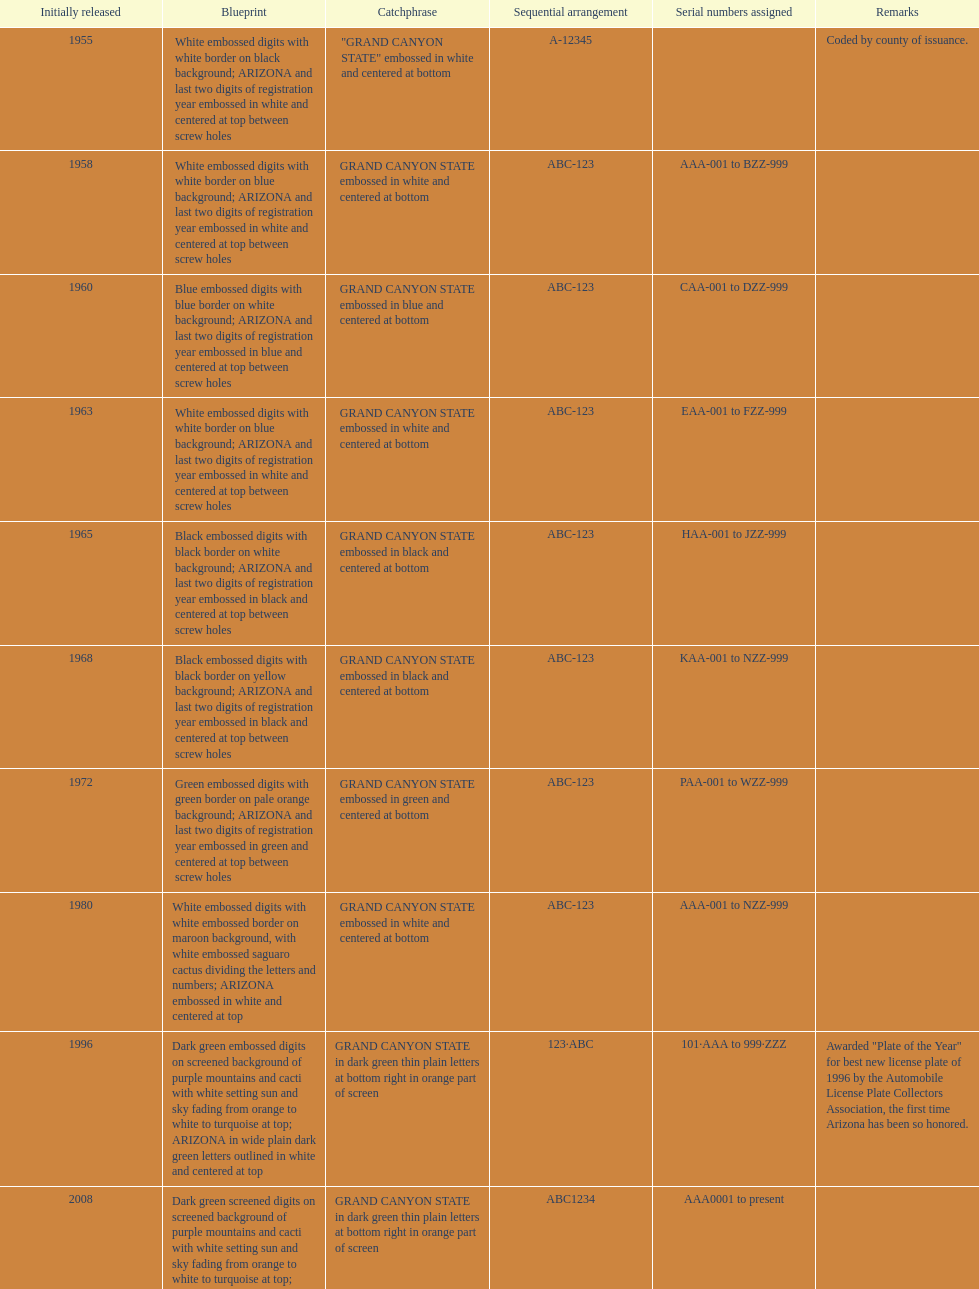What was year was the first arizona license plate made? 1955. 